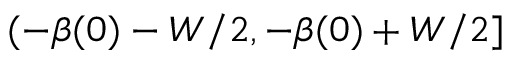Convert formula to latex. <formula><loc_0><loc_0><loc_500><loc_500>( - \beta ( 0 ) - W / 2 , - \beta ( 0 ) + W / 2 ]</formula> 